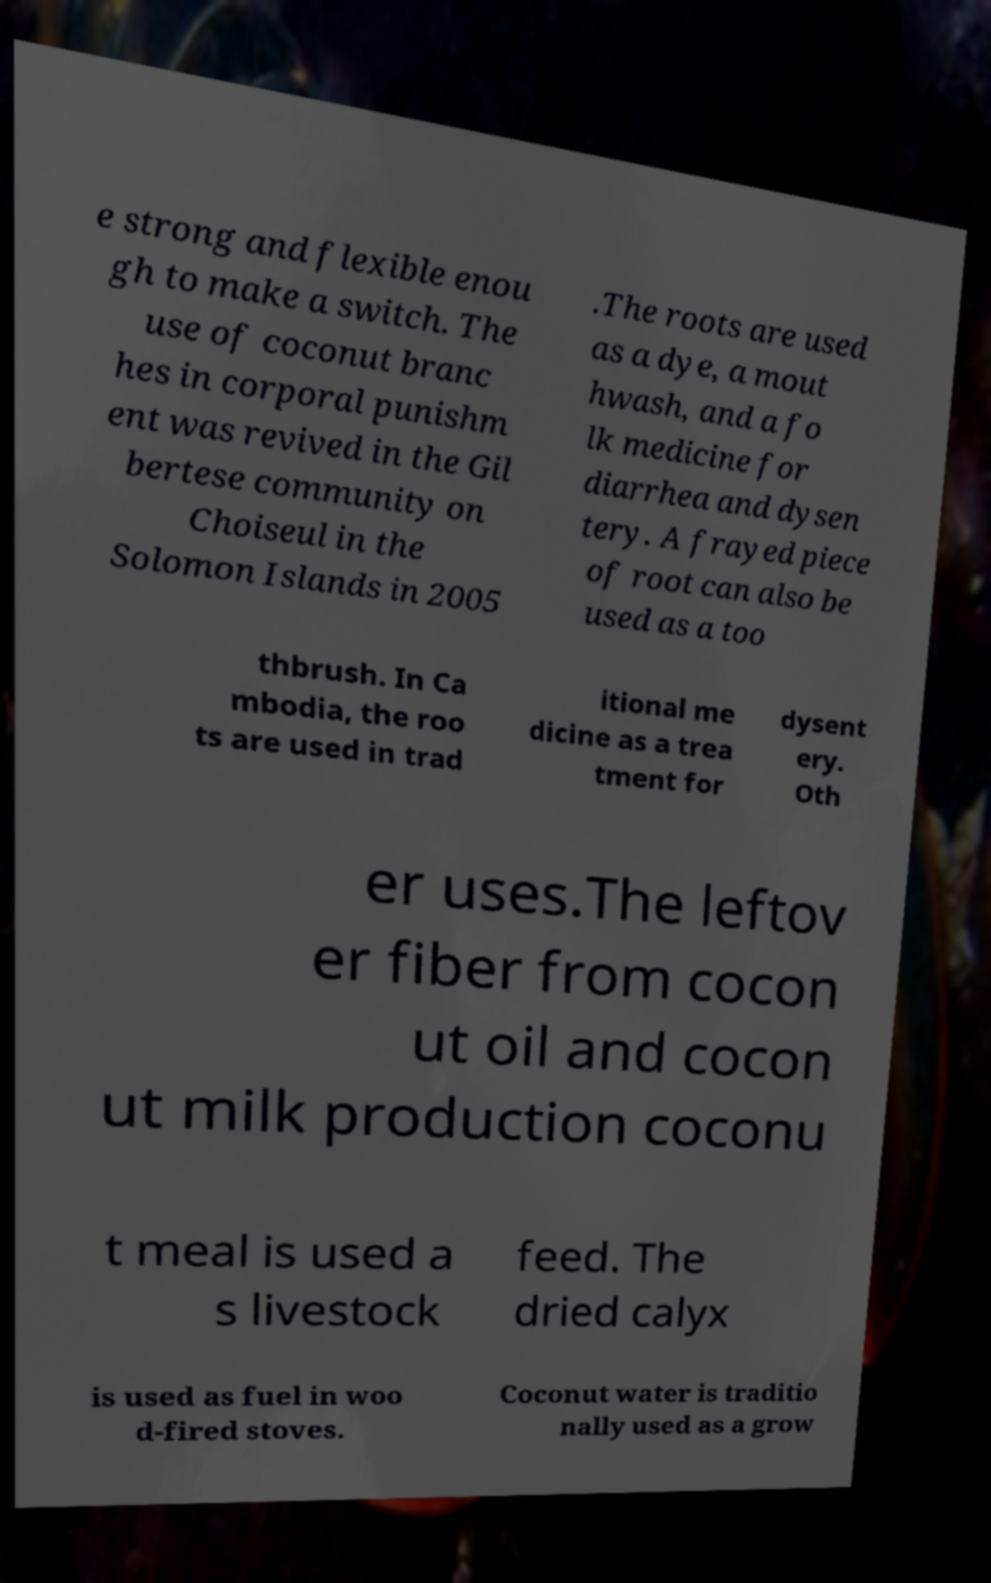Please identify and transcribe the text found in this image. e strong and flexible enou gh to make a switch. The use of coconut branc hes in corporal punishm ent was revived in the Gil bertese community on Choiseul in the Solomon Islands in 2005 .The roots are used as a dye, a mout hwash, and a fo lk medicine for diarrhea and dysen tery. A frayed piece of root can also be used as a too thbrush. In Ca mbodia, the roo ts are used in trad itional me dicine as a trea tment for dysent ery. Oth er uses.The leftov er fiber from cocon ut oil and cocon ut milk production coconu t meal is used a s livestock feed. The dried calyx is used as fuel in woo d-fired stoves. Coconut water is traditio nally used as a grow 